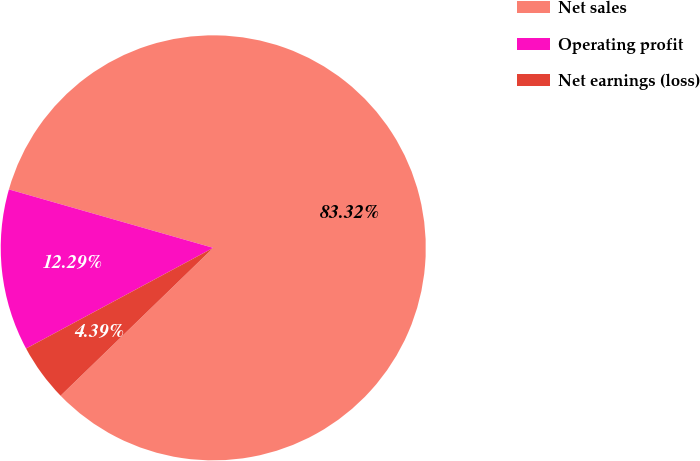Convert chart to OTSL. <chart><loc_0><loc_0><loc_500><loc_500><pie_chart><fcel>Net sales<fcel>Operating profit<fcel>Net earnings (loss)<nl><fcel>83.32%<fcel>12.29%<fcel>4.39%<nl></chart> 